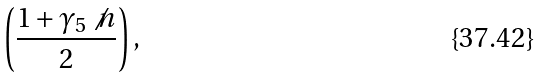Convert formula to latex. <formula><loc_0><loc_0><loc_500><loc_500>\left ( \frac { 1 + \gamma _ { 5 } \not { n } } { 2 } \right ) ,</formula> 